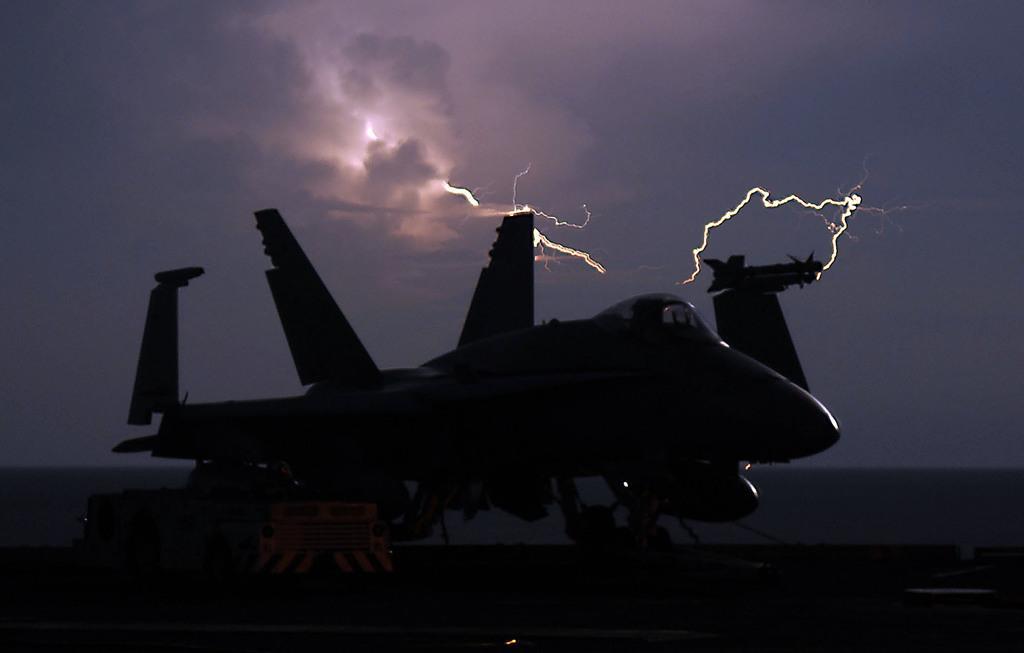Describe this image in one or two sentences. This is an image clicked in the dark. Here I can see a plane on the land. In the background, I can see the thunders in the sky. 